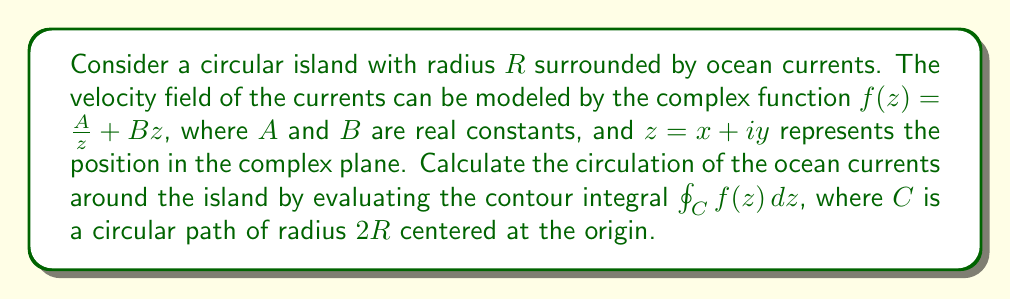Teach me how to tackle this problem. To solve this problem, we'll follow these steps:

1) The contour $C$ is a circle with radius $2R$ centered at the origin. We can parameterize this circle as $z = 2Re^{i\theta}$, where $0 \leq \theta \leq 2\pi$.

2) For this parameterization, $dz = 2Rie^{i\theta}d\theta$.

3) Substituting the parameterization into the function $f(z)$:

   $f(z) = \frac{A}{2Re^{i\theta}} + B(2Re^{i\theta})$

4) The contour integral becomes:

   $$\oint_C f(z) dz = \int_0^{2\pi} \left(\frac{A}{2Re^{i\theta}} + B(2Re^{i\theta})\right) (2Rie^{i\theta}d\theta)$$

5) Simplifying:

   $$= \int_0^{2\pi} \left(\frac{Ai}{R} + 4BR^2ie^{2i\theta}\right) d\theta$$

6) We can separate this into two integrals:

   $$= \frac{Ai}{R} \int_0^{2\pi} d\theta + 4BR^2i \int_0^{2\pi} e^{2i\theta} d\theta$$

7) The first integral is straightforward:

   $$\frac{Ai}{R} \int_0^{2\pi} d\theta = \frac{2\pi Ai}{R}$$

8) For the second integral, note that $\int_0^{2\pi} e^{in\theta} d\theta = 0$ for any non-zero integer $n$. Therefore:

   $$4BR^2i \int_0^{2\pi} e^{2i\theta} d\theta = 0$$

9) The final result is:

   $$\oint_C f(z) dz = \frac{2\pi Ai}{R}$$

This result represents the circulation of the ocean currents around the island. The imaginary part $2\pi A/R$ indicates the strength and direction of the circulation, while the factor $i$ shows that the circulation is perpendicular to the radial direction.
Answer: $$\oint_C f(z) dz = \frac{2\pi Ai}{R}$$ 